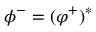<formula> <loc_0><loc_0><loc_500><loc_500>\phi ^ { - } = ( \varphi ^ { + } ) ^ { * }</formula> 